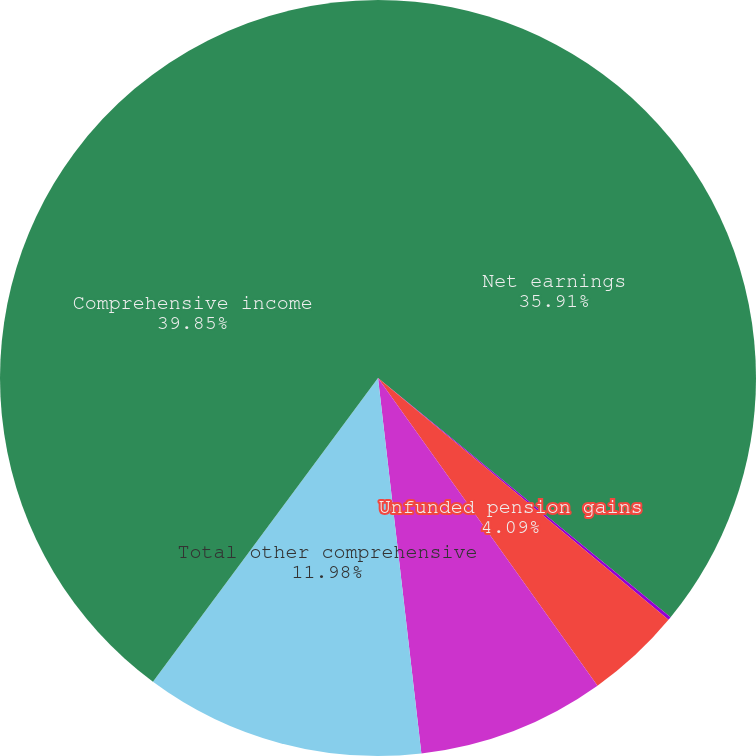Convert chart to OTSL. <chart><loc_0><loc_0><loc_500><loc_500><pie_chart><fcel>Net earnings<fcel>Unrealized gains (losses) on<fcel>Unfunded pension gains<fcel>Foreign currency translation<fcel>Total other comprehensive<fcel>Comprehensive income<nl><fcel>35.91%<fcel>0.14%<fcel>4.09%<fcel>8.03%<fcel>11.98%<fcel>39.85%<nl></chart> 